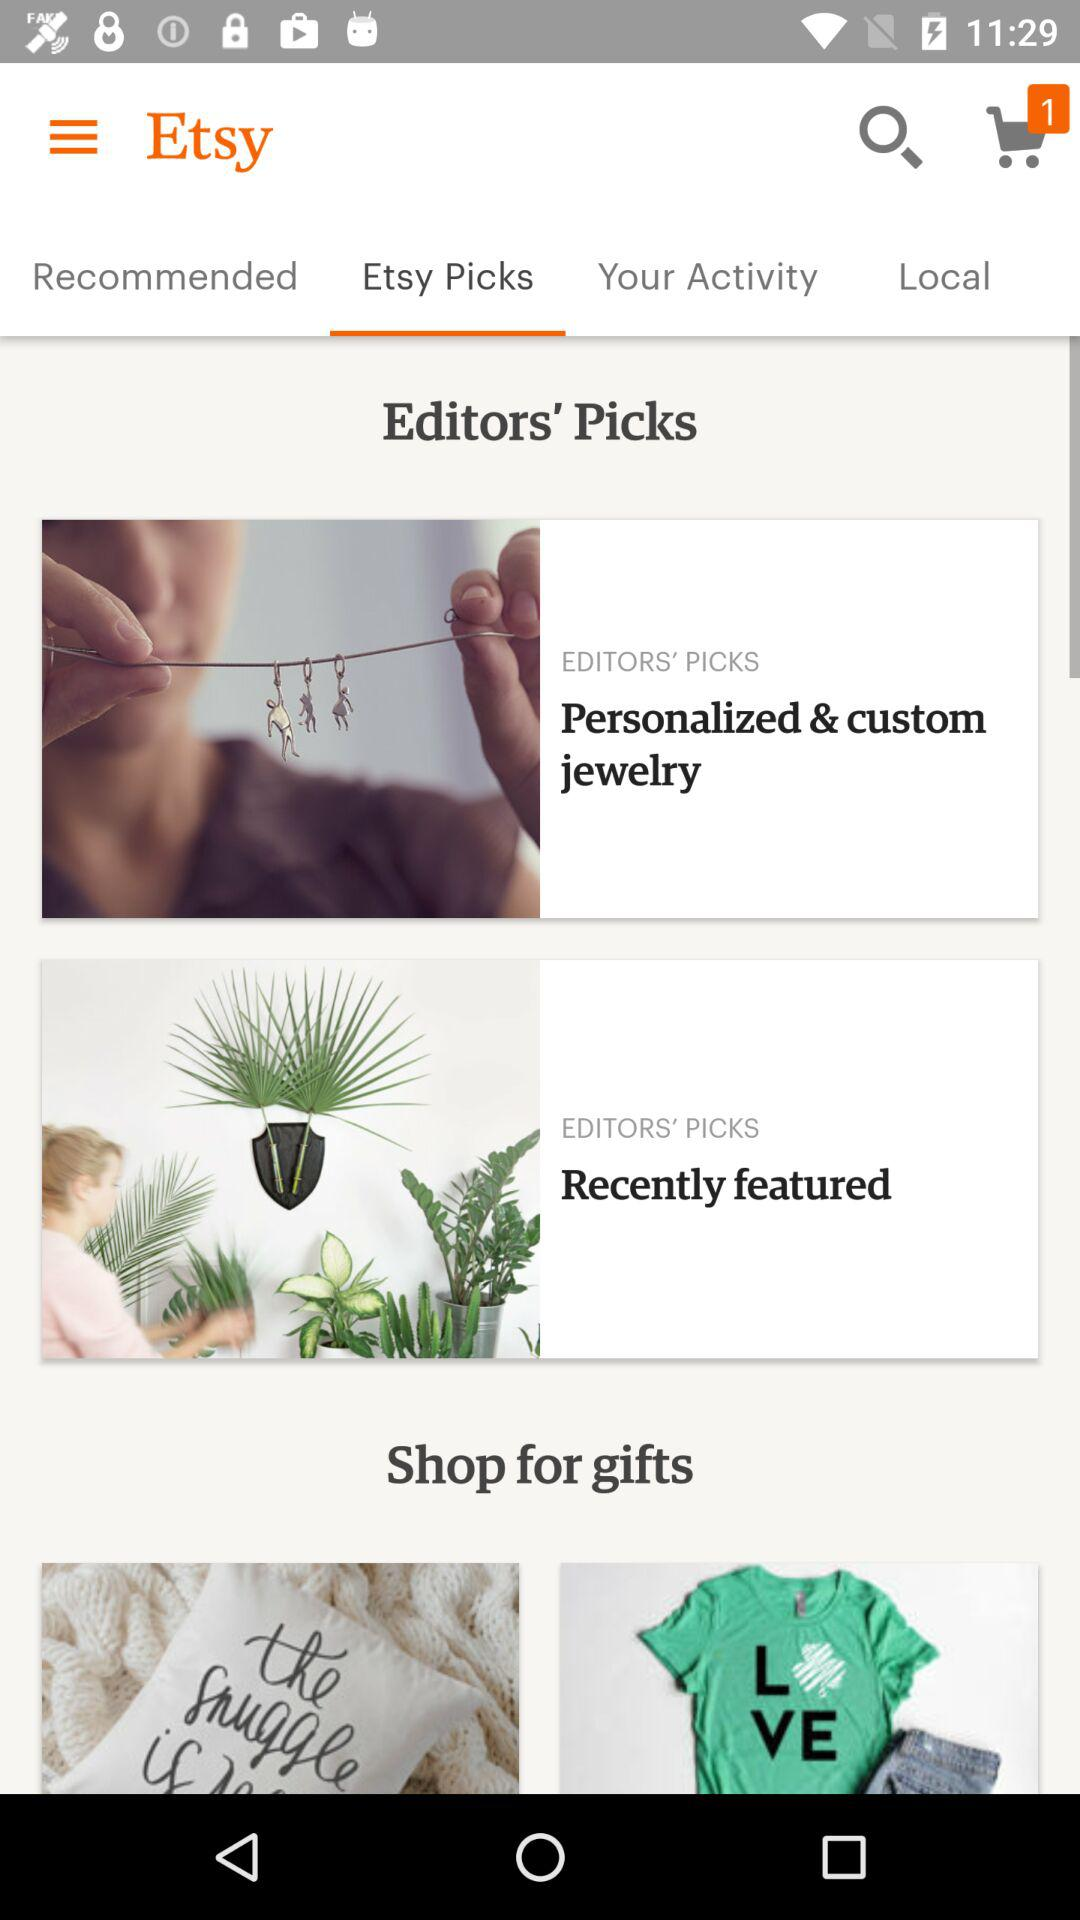Which tab has been selected? The tab that has been selected is "Etsy Picks". 